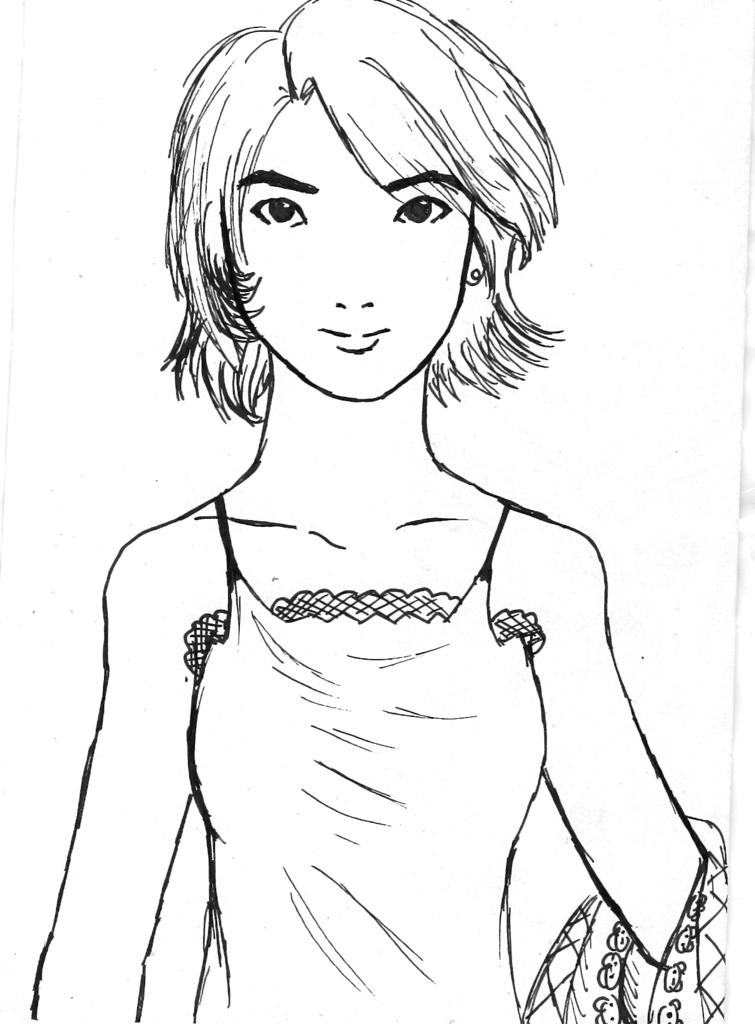What is the main subject of the sketch in the image? The main subject of the sketch in the image is a person. What is the person in the sketch wearing? The person in the sketch is wearing a dress. On what surface is the sketch made? The sketch is made on a white surface. What color is used to create the sketch? The sketch is made with a black colored pen. Reasoning: Let's think step by step by step in order to produce the conversation. We start by identifying the main subject of the sketch, which is a person. Then, we describe the clothing of the person in the sketch, which is a dress. Next, we mention the surface on which the sketch is made, which is white. Finally, we identify the color used to create the sketch, which is black. Each question is designed to elicit a specific detail about the image that is known from the provided facts. Absurd Question/Answer: How many strands of hair can be seen on the person's stomach in the sketch? There is no hair or stomach visible in the sketch; it only shows a person wearing a dress. Is there a hook hanging from the person's dress in the sketch? There is no hook visible in the sketch; it only shows a person wearing a dress. 